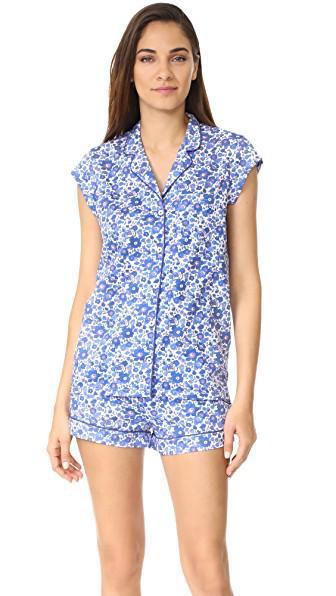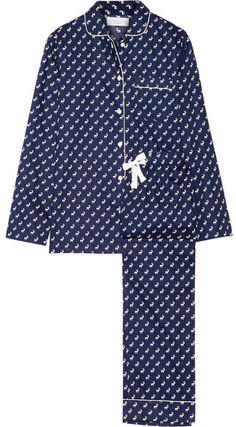The first image is the image on the left, the second image is the image on the right. Considering the images on both sides, is "Two pajama models are facing front and shown full length, each striking a pose similar to the other person." valid? Answer yes or no. No. The first image is the image on the left, the second image is the image on the right. For the images shown, is this caption "All models face forward and wear long pants, and at least one model wears dark pants with an all-over print." true? Answer yes or no. No. 